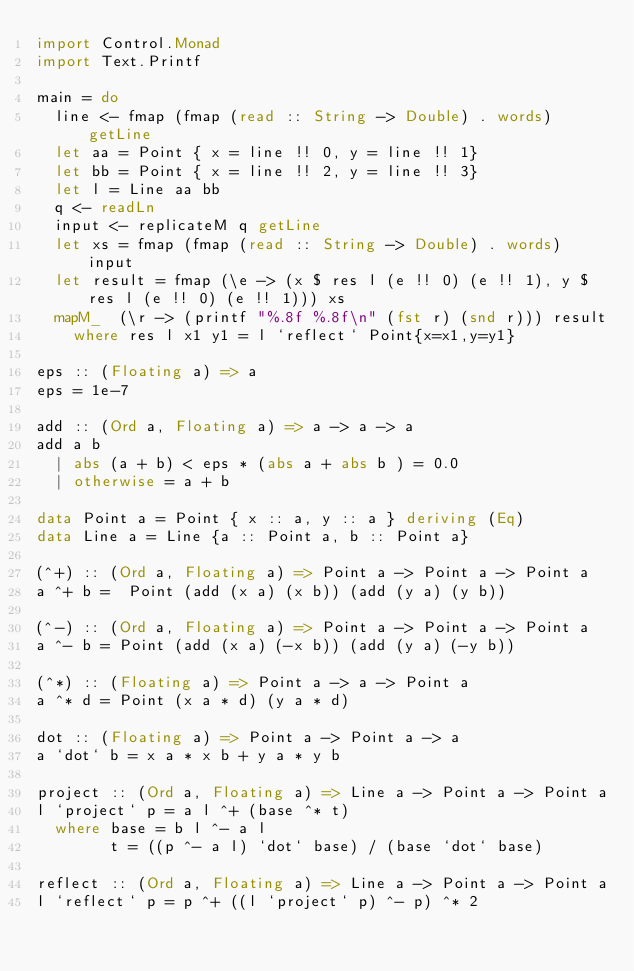Convert code to text. <code><loc_0><loc_0><loc_500><loc_500><_Haskell_>import Control.Monad
import Text.Printf

main = do
  line <- fmap (fmap (read :: String -> Double) . words) getLine
  let aa = Point { x = line !! 0, y = line !! 1}
  let bb = Point { x = line !! 2, y = line !! 3}
  let l = Line aa bb
  q <- readLn
  input <- replicateM q getLine
  let xs = fmap (fmap (read :: String -> Double) . words) input
  let result = fmap (\e -> (x $ res l (e !! 0) (e !! 1), y $ res l (e !! 0) (e !! 1))) xs
  mapM_  (\r -> (printf "%.8f %.8f\n" (fst r) (snd r))) result
    where res l x1 y1 = l `reflect` Point{x=x1,y=y1}

eps :: (Floating a) => a
eps = 1e-7

add :: (Ord a, Floating a) => a -> a -> a
add a b
  | abs (a + b) < eps * (abs a + abs b ) = 0.0
  | otherwise = a + b

data Point a = Point { x :: a, y :: a } deriving (Eq)
data Line a = Line {a :: Point a, b :: Point a}

(^+) :: (Ord a, Floating a) => Point a -> Point a -> Point a
a ^+ b =  Point (add (x a) (x b)) (add (y a) (y b))

(^-) :: (Ord a, Floating a) => Point a -> Point a -> Point a
a ^- b = Point (add (x a) (-x b)) (add (y a) (-y b))

(^*) :: (Floating a) => Point a -> a -> Point a
a ^* d = Point (x a * d) (y a * d)

dot :: (Floating a) => Point a -> Point a -> a
a `dot` b = x a * x b + y a * y b

project :: (Ord a, Floating a) => Line a -> Point a -> Point a
l `project` p = a l ^+ (base ^* t)
  where base = b l ^- a l
        t = ((p ^- a l) `dot` base) / (base `dot` base)

reflect :: (Ord a, Floating a) => Line a -> Point a -> Point a
l `reflect` p = p ^+ ((l `project` p) ^- p) ^* 2</code> 